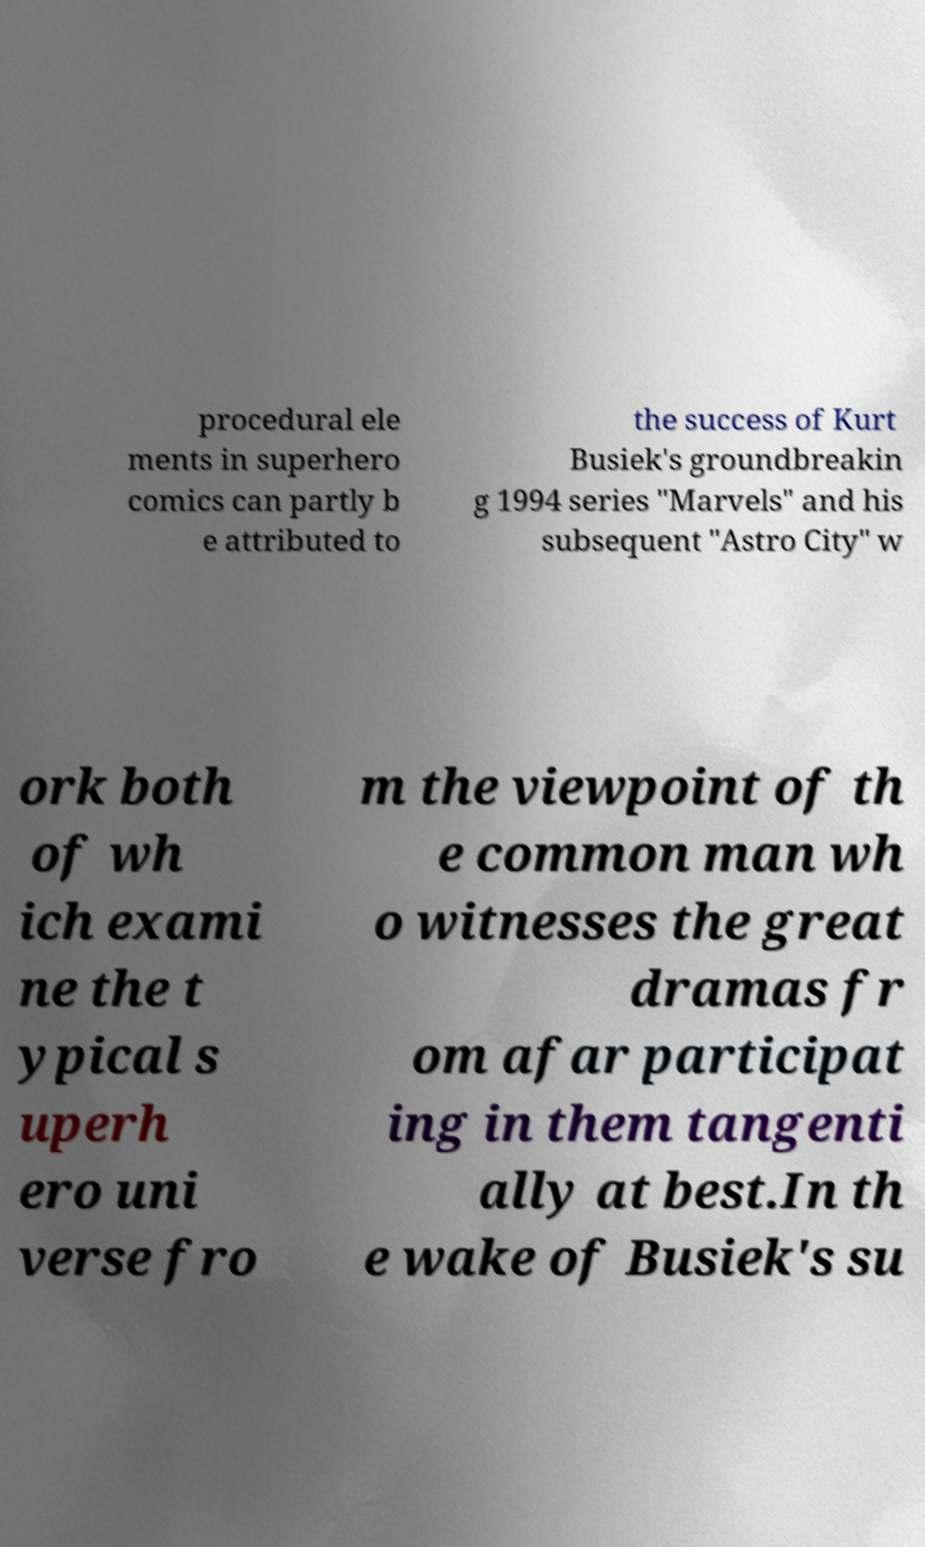For documentation purposes, I need the text within this image transcribed. Could you provide that? procedural ele ments in superhero comics can partly b e attributed to the success of Kurt Busiek's groundbreakin g 1994 series "Marvels" and his subsequent "Astro City" w ork both of wh ich exami ne the t ypical s uperh ero uni verse fro m the viewpoint of th e common man wh o witnesses the great dramas fr om afar participat ing in them tangenti ally at best.In th e wake of Busiek's su 